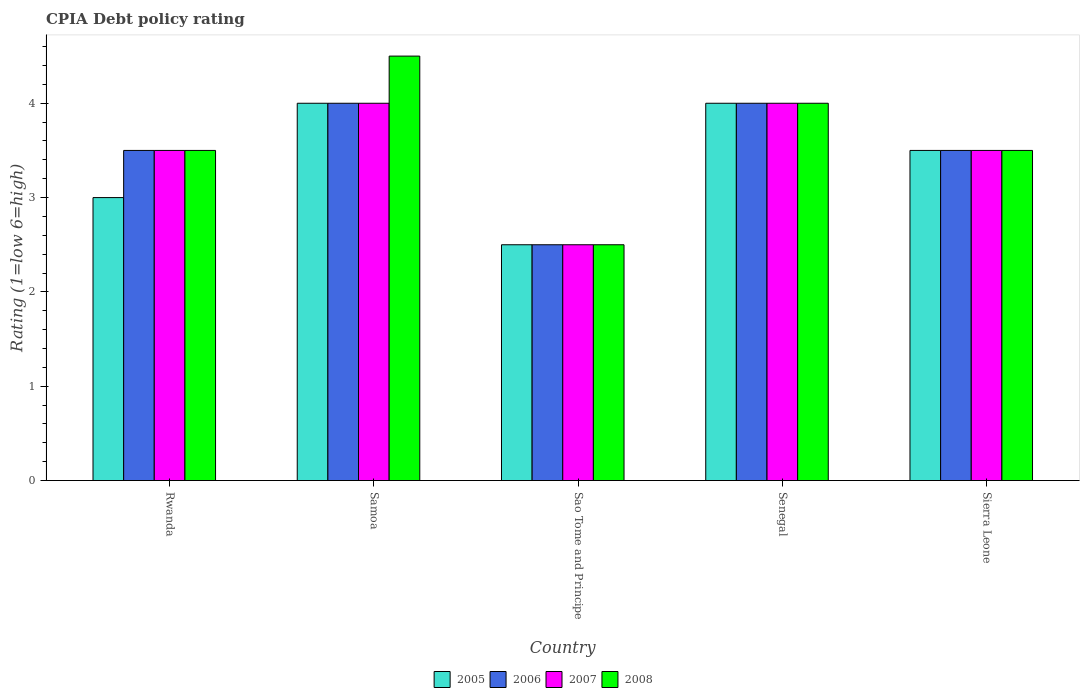How many different coloured bars are there?
Your response must be concise. 4. How many bars are there on the 1st tick from the left?
Your response must be concise. 4. What is the label of the 1st group of bars from the left?
Offer a very short reply. Rwanda. What is the CPIA rating in 2007 in Sao Tome and Principe?
Your response must be concise. 2.5. Across all countries, what is the minimum CPIA rating in 2005?
Make the answer very short. 2.5. In which country was the CPIA rating in 2008 maximum?
Provide a succinct answer. Samoa. In which country was the CPIA rating in 2005 minimum?
Keep it short and to the point. Sao Tome and Principe. What is the total CPIA rating in 2007 in the graph?
Your answer should be compact. 17.5. What is the difference between the CPIA rating in 2007 in Rwanda and that in Samoa?
Your response must be concise. -0.5. What is the difference between the CPIA rating of/in 2008 and CPIA rating of/in 2006 in Sao Tome and Principe?
Keep it short and to the point. 0. In how many countries, is the CPIA rating in 2006 greater than 3.2?
Offer a terse response. 4. Is the difference between the CPIA rating in 2008 in Senegal and Sierra Leone greater than the difference between the CPIA rating in 2006 in Senegal and Sierra Leone?
Ensure brevity in your answer.  No. Is the sum of the CPIA rating in 2006 in Samoa and Sierra Leone greater than the maximum CPIA rating in 2008 across all countries?
Your response must be concise. Yes. Is it the case that in every country, the sum of the CPIA rating in 2008 and CPIA rating in 2006 is greater than the CPIA rating in 2007?
Make the answer very short. Yes. Are all the bars in the graph horizontal?
Keep it short and to the point. No. Are the values on the major ticks of Y-axis written in scientific E-notation?
Offer a terse response. No. Does the graph contain grids?
Your response must be concise. No. Where does the legend appear in the graph?
Offer a very short reply. Bottom center. How are the legend labels stacked?
Your answer should be compact. Horizontal. What is the title of the graph?
Offer a very short reply. CPIA Debt policy rating. What is the label or title of the X-axis?
Provide a short and direct response. Country. What is the Rating (1=low 6=high) of 2006 in Rwanda?
Provide a succinct answer. 3.5. What is the Rating (1=low 6=high) of 2007 in Rwanda?
Provide a short and direct response. 3.5. What is the Rating (1=low 6=high) of 2005 in Samoa?
Your response must be concise. 4. What is the Rating (1=low 6=high) in 2008 in Samoa?
Give a very brief answer. 4.5. What is the Rating (1=low 6=high) of 2007 in Sao Tome and Principe?
Keep it short and to the point. 2.5. What is the Rating (1=low 6=high) of 2005 in Senegal?
Your answer should be very brief. 4. What is the Rating (1=low 6=high) of 2006 in Senegal?
Your response must be concise. 4. What is the Rating (1=low 6=high) in 2008 in Senegal?
Your response must be concise. 4. What is the Rating (1=low 6=high) in 2006 in Sierra Leone?
Your response must be concise. 3.5. Across all countries, what is the maximum Rating (1=low 6=high) in 2005?
Keep it short and to the point. 4. Across all countries, what is the maximum Rating (1=low 6=high) of 2006?
Provide a succinct answer. 4. Across all countries, what is the maximum Rating (1=low 6=high) in 2008?
Ensure brevity in your answer.  4.5. Across all countries, what is the minimum Rating (1=low 6=high) in 2006?
Your answer should be very brief. 2.5. Across all countries, what is the minimum Rating (1=low 6=high) of 2007?
Make the answer very short. 2.5. What is the total Rating (1=low 6=high) in 2006 in the graph?
Give a very brief answer. 17.5. What is the total Rating (1=low 6=high) of 2007 in the graph?
Give a very brief answer. 17.5. What is the total Rating (1=low 6=high) of 2008 in the graph?
Offer a very short reply. 18. What is the difference between the Rating (1=low 6=high) of 2007 in Rwanda and that in Samoa?
Offer a terse response. -0.5. What is the difference between the Rating (1=low 6=high) of 2008 in Rwanda and that in Samoa?
Give a very brief answer. -1. What is the difference between the Rating (1=low 6=high) of 2005 in Rwanda and that in Sao Tome and Principe?
Provide a succinct answer. 0.5. What is the difference between the Rating (1=low 6=high) of 2006 in Rwanda and that in Sao Tome and Principe?
Provide a succinct answer. 1. What is the difference between the Rating (1=low 6=high) in 2007 in Rwanda and that in Sao Tome and Principe?
Make the answer very short. 1. What is the difference between the Rating (1=low 6=high) in 2008 in Rwanda and that in Sao Tome and Principe?
Your response must be concise. 1. What is the difference between the Rating (1=low 6=high) of 2005 in Rwanda and that in Senegal?
Offer a very short reply. -1. What is the difference between the Rating (1=low 6=high) of 2006 in Rwanda and that in Senegal?
Keep it short and to the point. -0.5. What is the difference between the Rating (1=low 6=high) of 2007 in Rwanda and that in Senegal?
Your response must be concise. -0.5. What is the difference between the Rating (1=low 6=high) of 2005 in Rwanda and that in Sierra Leone?
Make the answer very short. -0.5. What is the difference between the Rating (1=low 6=high) of 2006 in Samoa and that in Sao Tome and Principe?
Offer a terse response. 1.5. What is the difference between the Rating (1=low 6=high) in 2007 in Samoa and that in Sao Tome and Principe?
Your response must be concise. 1.5. What is the difference between the Rating (1=low 6=high) in 2008 in Samoa and that in Sao Tome and Principe?
Ensure brevity in your answer.  2. What is the difference between the Rating (1=low 6=high) in 2005 in Samoa and that in Senegal?
Your answer should be compact. 0. What is the difference between the Rating (1=low 6=high) in 2007 in Samoa and that in Senegal?
Your answer should be compact. 0. What is the difference between the Rating (1=low 6=high) of 2005 in Samoa and that in Sierra Leone?
Offer a very short reply. 0.5. What is the difference between the Rating (1=low 6=high) in 2006 in Samoa and that in Sierra Leone?
Provide a succinct answer. 0.5. What is the difference between the Rating (1=low 6=high) of 2008 in Samoa and that in Sierra Leone?
Ensure brevity in your answer.  1. What is the difference between the Rating (1=low 6=high) of 2007 in Sao Tome and Principe and that in Senegal?
Your response must be concise. -1.5. What is the difference between the Rating (1=low 6=high) of 2008 in Sao Tome and Principe and that in Senegal?
Provide a short and direct response. -1.5. What is the difference between the Rating (1=low 6=high) in 2005 in Sao Tome and Principe and that in Sierra Leone?
Your answer should be compact. -1. What is the difference between the Rating (1=low 6=high) in 2005 in Senegal and that in Sierra Leone?
Offer a terse response. 0.5. What is the difference between the Rating (1=low 6=high) in 2007 in Senegal and that in Sierra Leone?
Keep it short and to the point. 0.5. What is the difference between the Rating (1=low 6=high) of 2005 in Rwanda and the Rating (1=low 6=high) of 2007 in Samoa?
Give a very brief answer. -1. What is the difference between the Rating (1=low 6=high) of 2006 in Rwanda and the Rating (1=low 6=high) of 2008 in Samoa?
Offer a very short reply. -1. What is the difference between the Rating (1=low 6=high) of 2007 in Rwanda and the Rating (1=low 6=high) of 2008 in Samoa?
Offer a very short reply. -1. What is the difference between the Rating (1=low 6=high) in 2006 in Rwanda and the Rating (1=low 6=high) in 2007 in Sao Tome and Principe?
Offer a terse response. 1. What is the difference between the Rating (1=low 6=high) in 2006 in Rwanda and the Rating (1=low 6=high) in 2008 in Sao Tome and Principe?
Provide a succinct answer. 1. What is the difference between the Rating (1=low 6=high) of 2005 in Rwanda and the Rating (1=low 6=high) of 2006 in Senegal?
Your answer should be very brief. -1. What is the difference between the Rating (1=low 6=high) of 2005 in Rwanda and the Rating (1=low 6=high) of 2007 in Senegal?
Make the answer very short. -1. What is the difference between the Rating (1=low 6=high) of 2005 in Rwanda and the Rating (1=low 6=high) of 2008 in Senegal?
Offer a very short reply. -1. What is the difference between the Rating (1=low 6=high) of 2006 in Rwanda and the Rating (1=low 6=high) of 2008 in Senegal?
Ensure brevity in your answer.  -0.5. What is the difference between the Rating (1=low 6=high) of 2005 in Rwanda and the Rating (1=low 6=high) of 2008 in Sierra Leone?
Your answer should be compact. -0.5. What is the difference between the Rating (1=low 6=high) in 2006 in Rwanda and the Rating (1=low 6=high) in 2007 in Sierra Leone?
Give a very brief answer. 0. What is the difference between the Rating (1=low 6=high) in 2007 in Rwanda and the Rating (1=low 6=high) in 2008 in Sierra Leone?
Offer a terse response. 0. What is the difference between the Rating (1=low 6=high) of 2005 in Samoa and the Rating (1=low 6=high) of 2006 in Sao Tome and Principe?
Offer a very short reply. 1.5. What is the difference between the Rating (1=low 6=high) of 2005 in Samoa and the Rating (1=low 6=high) of 2008 in Sao Tome and Principe?
Provide a short and direct response. 1.5. What is the difference between the Rating (1=low 6=high) in 2006 in Samoa and the Rating (1=low 6=high) in 2007 in Sao Tome and Principe?
Your answer should be very brief. 1.5. What is the difference between the Rating (1=low 6=high) of 2007 in Samoa and the Rating (1=low 6=high) of 2008 in Sao Tome and Principe?
Offer a terse response. 1.5. What is the difference between the Rating (1=low 6=high) in 2005 in Samoa and the Rating (1=low 6=high) in 2007 in Senegal?
Your answer should be compact. 0. What is the difference between the Rating (1=low 6=high) of 2006 in Samoa and the Rating (1=low 6=high) of 2007 in Senegal?
Keep it short and to the point. 0. What is the difference between the Rating (1=low 6=high) in 2005 in Samoa and the Rating (1=low 6=high) in 2006 in Sierra Leone?
Provide a short and direct response. 0.5. What is the difference between the Rating (1=low 6=high) of 2005 in Samoa and the Rating (1=low 6=high) of 2007 in Sierra Leone?
Keep it short and to the point. 0.5. What is the difference between the Rating (1=low 6=high) in 2006 in Samoa and the Rating (1=low 6=high) in 2007 in Sierra Leone?
Provide a short and direct response. 0.5. What is the difference between the Rating (1=low 6=high) in 2007 in Samoa and the Rating (1=low 6=high) in 2008 in Sierra Leone?
Your answer should be compact. 0.5. What is the difference between the Rating (1=low 6=high) of 2006 in Sao Tome and Principe and the Rating (1=low 6=high) of 2008 in Senegal?
Your answer should be very brief. -1.5. What is the difference between the Rating (1=low 6=high) of 2007 in Sao Tome and Principe and the Rating (1=low 6=high) of 2008 in Senegal?
Provide a short and direct response. -1.5. What is the difference between the Rating (1=low 6=high) of 2005 in Sao Tome and Principe and the Rating (1=low 6=high) of 2006 in Sierra Leone?
Your answer should be very brief. -1. What is the difference between the Rating (1=low 6=high) of 2005 in Sao Tome and Principe and the Rating (1=low 6=high) of 2007 in Sierra Leone?
Your answer should be very brief. -1. What is the difference between the Rating (1=low 6=high) of 2005 in Sao Tome and Principe and the Rating (1=low 6=high) of 2008 in Sierra Leone?
Give a very brief answer. -1. What is the difference between the Rating (1=low 6=high) of 2006 in Sao Tome and Principe and the Rating (1=low 6=high) of 2007 in Sierra Leone?
Keep it short and to the point. -1. What is the difference between the Rating (1=low 6=high) of 2006 in Sao Tome and Principe and the Rating (1=low 6=high) of 2008 in Sierra Leone?
Keep it short and to the point. -1. What is the difference between the Rating (1=low 6=high) in 2007 in Sao Tome and Principe and the Rating (1=low 6=high) in 2008 in Sierra Leone?
Your answer should be compact. -1. What is the difference between the Rating (1=low 6=high) of 2005 in Senegal and the Rating (1=low 6=high) of 2008 in Sierra Leone?
Your response must be concise. 0.5. What is the average Rating (1=low 6=high) in 2005 per country?
Keep it short and to the point. 3.4. What is the difference between the Rating (1=low 6=high) in 2005 and Rating (1=low 6=high) in 2006 in Rwanda?
Keep it short and to the point. -0.5. What is the difference between the Rating (1=low 6=high) of 2005 and Rating (1=low 6=high) of 2007 in Rwanda?
Your response must be concise. -0.5. What is the difference between the Rating (1=low 6=high) in 2005 and Rating (1=low 6=high) in 2008 in Rwanda?
Provide a succinct answer. -0.5. What is the difference between the Rating (1=low 6=high) of 2006 and Rating (1=low 6=high) of 2008 in Rwanda?
Offer a terse response. 0. What is the difference between the Rating (1=low 6=high) of 2005 and Rating (1=low 6=high) of 2006 in Samoa?
Your answer should be compact. 0. What is the difference between the Rating (1=low 6=high) of 2005 and Rating (1=low 6=high) of 2008 in Samoa?
Keep it short and to the point. -0.5. What is the difference between the Rating (1=low 6=high) in 2006 and Rating (1=low 6=high) in 2007 in Samoa?
Provide a short and direct response. 0. What is the difference between the Rating (1=low 6=high) of 2006 and Rating (1=low 6=high) of 2008 in Samoa?
Your answer should be compact. -0.5. What is the difference between the Rating (1=low 6=high) of 2007 and Rating (1=low 6=high) of 2008 in Samoa?
Provide a succinct answer. -0.5. What is the difference between the Rating (1=low 6=high) in 2005 and Rating (1=low 6=high) in 2006 in Sao Tome and Principe?
Your answer should be very brief. 0. What is the difference between the Rating (1=low 6=high) in 2005 and Rating (1=low 6=high) in 2007 in Sao Tome and Principe?
Provide a short and direct response. 0. What is the difference between the Rating (1=low 6=high) in 2005 and Rating (1=low 6=high) in 2008 in Sao Tome and Principe?
Offer a terse response. 0. What is the difference between the Rating (1=low 6=high) in 2005 and Rating (1=low 6=high) in 2007 in Senegal?
Your response must be concise. 0. What is the difference between the Rating (1=low 6=high) in 2006 and Rating (1=low 6=high) in 2007 in Senegal?
Keep it short and to the point. 0. What is the difference between the Rating (1=low 6=high) in 2007 and Rating (1=low 6=high) in 2008 in Senegal?
Offer a very short reply. 0. What is the difference between the Rating (1=low 6=high) in 2005 and Rating (1=low 6=high) in 2007 in Sierra Leone?
Keep it short and to the point. 0. What is the difference between the Rating (1=low 6=high) of 2005 and Rating (1=low 6=high) of 2008 in Sierra Leone?
Offer a terse response. 0. What is the ratio of the Rating (1=low 6=high) in 2007 in Rwanda to that in Samoa?
Keep it short and to the point. 0.88. What is the ratio of the Rating (1=low 6=high) in 2005 in Rwanda to that in Sao Tome and Principe?
Your response must be concise. 1.2. What is the ratio of the Rating (1=low 6=high) of 2008 in Rwanda to that in Sao Tome and Principe?
Provide a succinct answer. 1.4. What is the ratio of the Rating (1=low 6=high) in 2006 in Rwanda to that in Senegal?
Your answer should be compact. 0.88. What is the ratio of the Rating (1=low 6=high) of 2008 in Rwanda to that in Senegal?
Your answer should be compact. 0.88. What is the ratio of the Rating (1=low 6=high) in 2005 in Samoa to that in Sao Tome and Principe?
Your response must be concise. 1.6. What is the ratio of the Rating (1=low 6=high) in 2006 in Samoa to that in Sao Tome and Principe?
Provide a succinct answer. 1.6. What is the ratio of the Rating (1=low 6=high) in 2008 in Samoa to that in Sao Tome and Principe?
Keep it short and to the point. 1.8. What is the ratio of the Rating (1=low 6=high) in 2006 in Samoa to that in Senegal?
Ensure brevity in your answer.  1. What is the ratio of the Rating (1=low 6=high) of 2005 in Samoa to that in Sierra Leone?
Keep it short and to the point. 1.14. What is the ratio of the Rating (1=low 6=high) in 2006 in Samoa to that in Sierra Leone?
Your answer should be compact. 1.14. What is the ratio of the Rating (1=low 6=high) in 2007 in Samoa to that in Sierra Leone?
Keep it short and to the point. 1.14. What is the ratio of the Rating (1=low 6=high) in 2008 in Samoa to that in Sierra Leone?
Your response must be concise. 1.29. What is the ratio of the Rating (1=low 6=high) of 2006 in Sao Tome and Principe to that in Senegal?
Your response must be concise. 0.62. What is the ratio of the Rating (1=low 6=high) of 2007 in Sao Tome and Principe to that in Senegal?
Provide a succinct answer. 0.62. What is the ratio of the Rating (1=low 6=high) of 2008 in Sao Tome and Principe to that in Senegal?
Your answer should be very brief. 0.62. What is the ratio of the Rating (1=low 6=high) of 2006 in Senegal to that in Sierra Leone?
Your answer should be compact. 1.14. What is the ratio of the Rating (1=low 6=high) of 2008 in Senegal to that in Sierra Leone?
Your response must be concise. 1.14. What is the difference between the highest and the second highest Rating (1=low 6=high) in 2005?
Offer a very short reply. 0. What is the difference between the highest and the second highest Rating (1=low 6=high) in 2007?
Provide a short and direct response. 0. What is the difference between the highest and the second highest Rating (1=low 6=high) in 2008?
Make the answer very short. 0.5. What is the difference between the highest and the lowest Rating (1=low 6=high) in 2006?
Provide a succinct answer. 1.5. What is the difference between the highest and the lowest Rating (1=low 6=high) in 2008?
Make the answer very short. 2. 